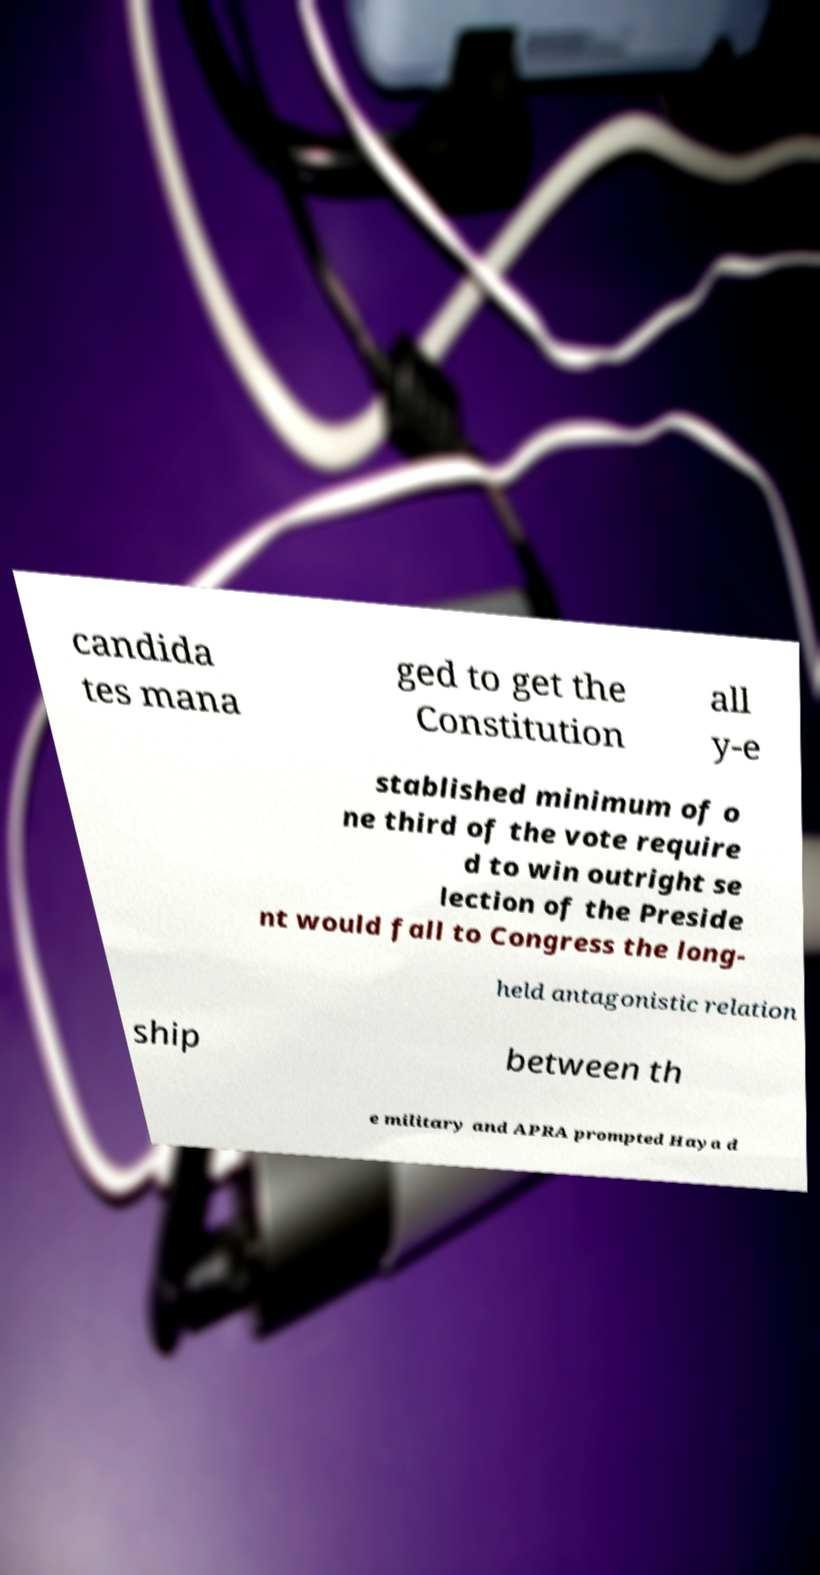I need the written content from this picture converted into text. Can you do that? candida tes mana ged to get the Constitution all y-e stablished minimum of o ne third of the vote require d to win outright se lection of the Preside nt would fall to Congress the long- held antagonistic relation ship between th e military and APRA prompted Haya d 